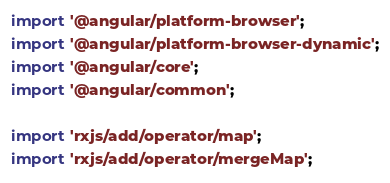Convert code to text. <code><loc_0><loc_0><loc_500><loc_500><_TypeScript_>import '@angular/platform-browser';
import '@angular/platform-browser-dynamic';
import '@angular/core';
import '@angular/common';

import 'rxjs/add/operator/map';
import 'rxjs/add/operator/mergeMap';
</code> 